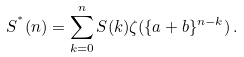Convert formula to latex. <formula><loc_0><loc_0><loc_500><loc_500>S ^ { ^ { * } } ( n ) = \sum _ { k = 0 } ^ { n } S ( k ) \zeta ( \{ a + b \} ^ { n - k } ) \, .</formula> 